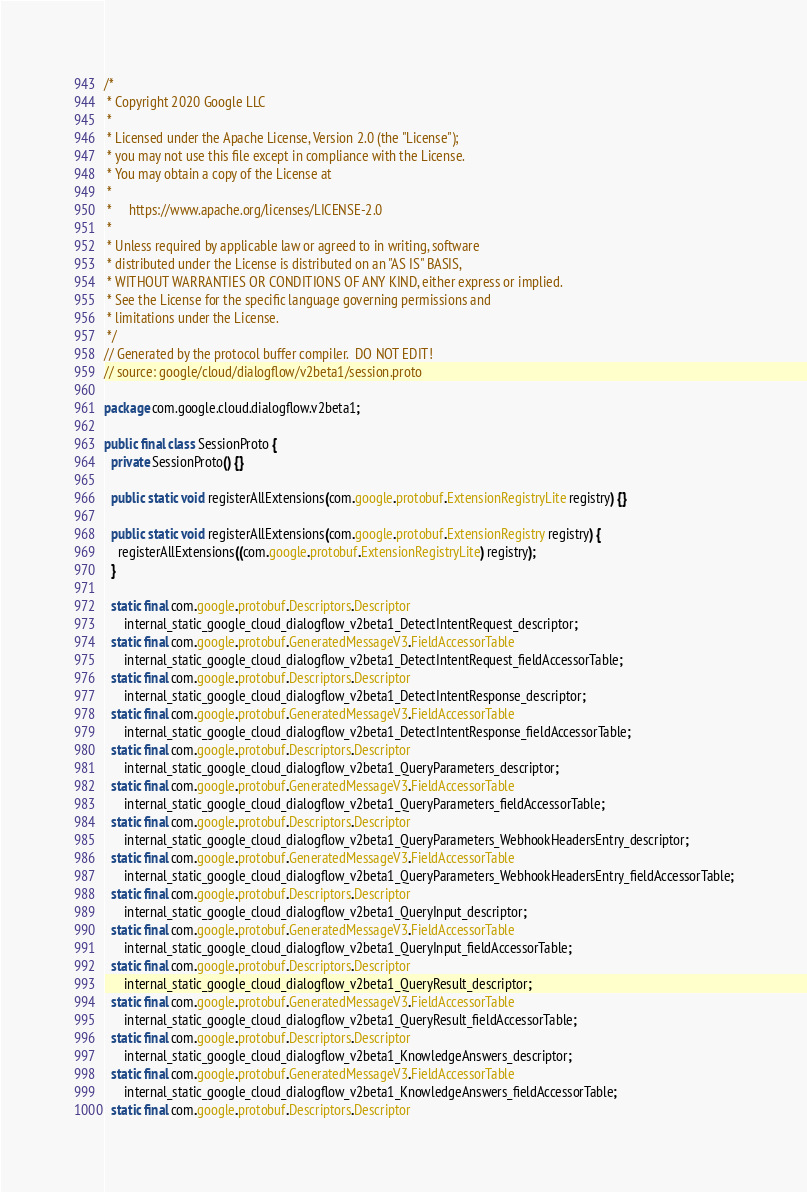Convert code to text. <code><loc_0><loc_0><loc_500><loc_500><_Java_>/*
 * Copyright 2020 Google LLC
 *
 * Licensed under the Apache License, Version 2.0 (the "License");
 * you may not use this file except in compliance with the License.
 * You may obtain a copy of the License at
 *
 *     https://www.apache.org/licenses/LICENSE-2.0
 *
 * Unless required by applicable law or agreed to in writing, software
 * distributed under the License is distributed on an "AS IS" BASIS,
 * WITHOUT WARRANTIES OR CONDITIONS OF ANY KIND, either express or implied.
 * See the License for the specific language governing permissions and
 * limitations under the License.
 */
// Generated by the protocol buffer compiler.  DO NOT EDIT!
// source: google/cloud/dialogflow/v2beta1/session.proto

package com.google.cloud.dialogflow.v2beta1;

public final class SessionProto {
  private SessionProto() {}

  public static void registerAllExtensions(com.google.protobuf.ExtensionRegistryLite registry) {}

  public static void registerAllExtensions(com.google.protobuf.ExtensionRegistry registry) {
    registerAllExtensions((com.google.protobuf.ExtensionRegistryLite) registry);
  }

  static final com.google.protobuf.Descriptors.Descriptor
      internal_static_google_cloud_dialogflow_v2beta1_DetectIntentRequest_descriptor;
  static final com.google.protobuf.GeneratedMessageV3.FieldAccessorTable
      internal_static_google_cloud_dialogflow_v2beta1_DetectIntentRequest_fieldAccessorTable;
  static final com.google.protobuf.Descriptors.Descriptor
      internal_static_google_cloud_dialogflow_v2beta1_DetectIntentResponse_descriptor;
  static final com.google.protobuf.GeneratedMessageV3.FieldAccessorTable
      internal_static_google_cloud_dialogflow_v2beta1_DetectIntentResponse_fieldAccessorTable;
  static final com.google.protobuf.Descriptors.Descriptor
      internal_static_google_cloud_dialogflow_v2beta1_QueryParameters_descriptor;
  static final com.google.protobuf.GeneratedMessageV3.FieldAccessorTable
      internal_static_google_cloud_dialogflow_v2beta1_QueryParameters_fieldAccessorTable;
  static final com.google.protobuf.Descriptors.Descriptor
      internal_static_google_cloud_dialogflow_v2beta1_QueryParameters_WebhookHeadersEntry_descriptor;
  static final com.google.protobuf.GeneratedMessageV3.FieldAccessorTable
      internal_static_google_cloud_dialogflow_v2beta1_QueryParameters_WebhookHeadersEntry_fieldAccessorTable;
  static final com.google.protobuf.Descriptors.Descriptor
      internal_static_google_cloud_dialogflow_v2beta1_QueryInput_descriptor;
  static final com.google.protobuf.GeneratedMessageV3.FieldAccessorTable
      internal_static_google_cloud_dialogflow_v2beta1_QueryInput_fieldAccessorTable;
  static final com.google.protobuf.Descriptors.Descriptor
      internal_static_google_cloud_dialogflow_v2beta1_QueryResult_descriptor;
  static final com.google.protobuf.GeneratedMessageV3.FieldAccessorTable
      internal_static_google_cloud_dialogflow_v2beta1_QueryResult_fieldAccessorTable;
  static final com.google.protobuf.Descriptors.Descriptor
      internal_static_google_cloud_dialogflow_v2beta1_KnowledgeAnswers_descriptor;
  static final com.google.protobuf.GeneratedMessageV3.FieldAccessorTable
      internal_static_google_cloud_dialogflow_v2beta1_KnowledgeAnswers_fieldAccessorTable;
  static final com.google.protobuf.Descriptors.Descriptor</code> 